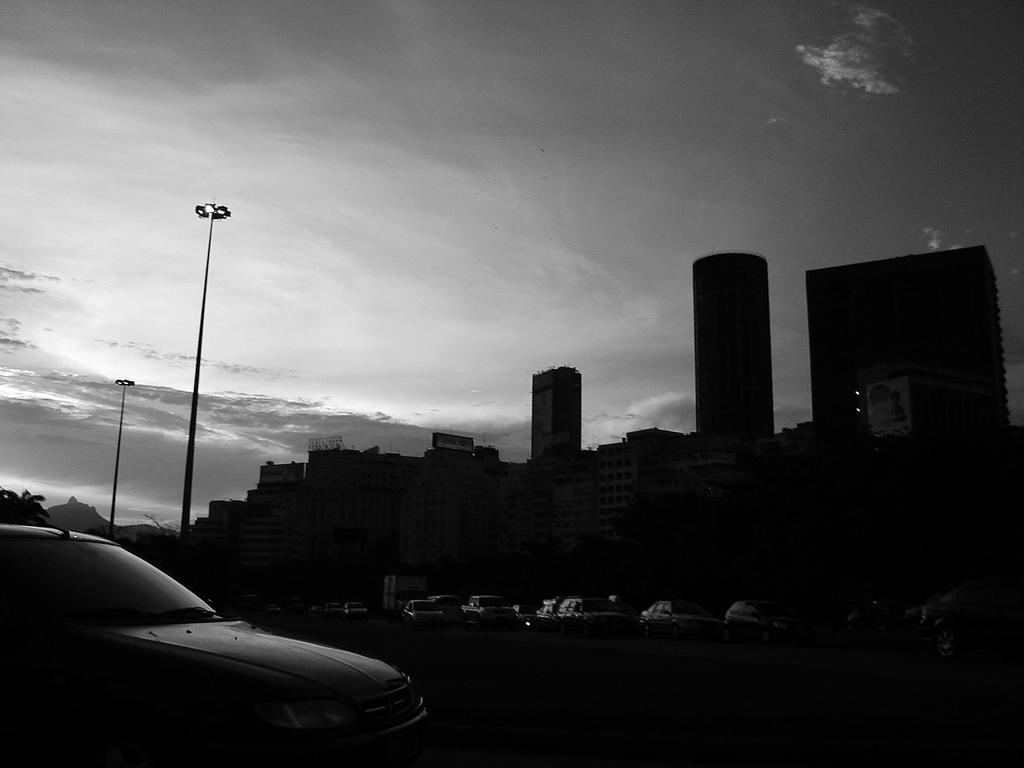What is the color scheme of the image? The image is black and white. What type of structures can be seen in the image? There are buildings in the image. What is happening on the road in the image? Vehicles are present on the road in the image. What type of natural elements are visible in the image? Trees are visible in the image. What else can be seen in the image besides buildings and trees? There are poles in the image. What is visible in the sky at the top of the image? Clouds are present in the sky at the top of the image. Can you tell me how many visitors are in the zoo in the image? There is no zoo or visitors present in the image; it features buildings, vehicles, trees, poles, and clouds. What type of ball is being used by the children in the image? There are no children or balls present in the image. 